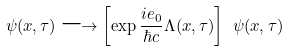<formula> <loc_0><loc_0><loc_500><loc_500>\psi ( x , \tau ) \longrightarrow \left [ \exp \frac { i e _ { 0 } } { \hbar { c } } \Lambda ( x , \tau ) \right ] \ \psi ( x , \tau )</formula> 